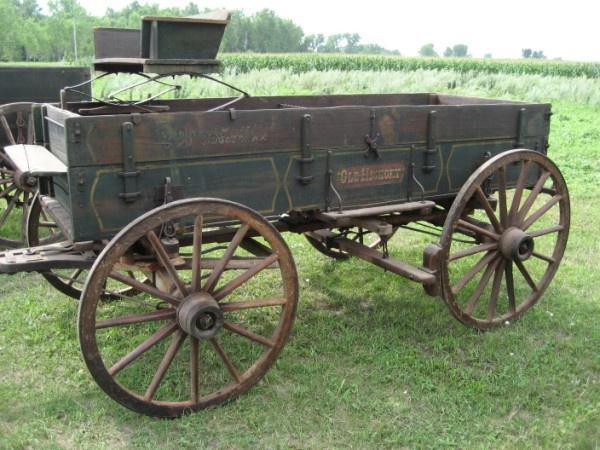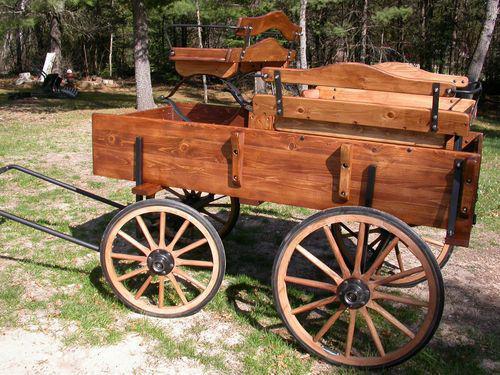The first image is the image on the left, the second image is the image on the right. Examine the images to the left and right. Is the description "There is a picture showing a horse hitched up to a piece of equipment." accurate? Answer yes or no. No. The first image is the image on the left, the second image is the image on the right. Examine the images to the left and right. Is the description "An image shows a brown horse harnessed to pull some type of wheeled thing." accurate? Answer yes or no. No. 